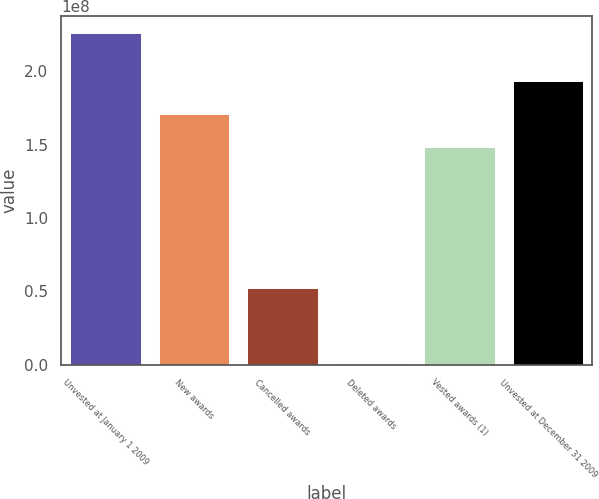Convert chart. <chart><loc_0><loc_0><loc_500><loc_500><bar_chart><fcel>Unvested at January 1 2009<fcel>New awards<fcel>Cancelled awards<fcel>Deleted awards<fcel>Vested awards (1)<fcel>Unvested at December 31 2009<nl><fcel>2.26211e+08<fcel>1.70576e+08<fcel>5.18738e+07<fcel>568377<fcel>1.48012e+08<fcel>1.9314e+08<nl></chart> 